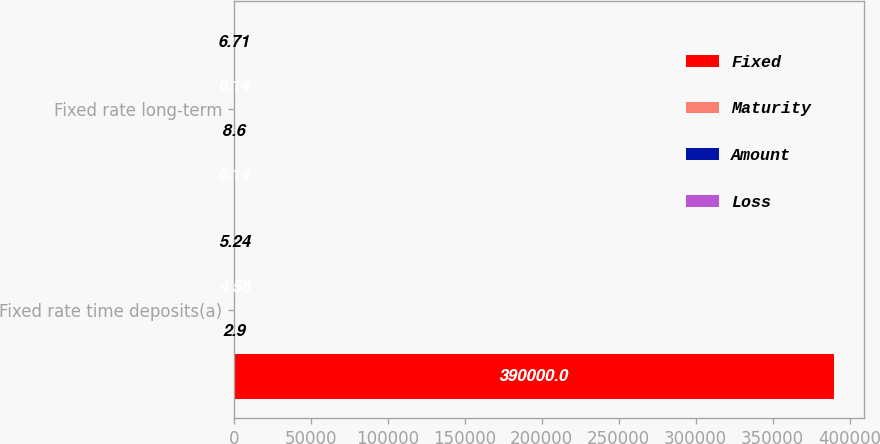<chart> <loc_0><loc_0><loc_500><loc_500><stacked_bar_chart><ecel><fcel>Fixed rate time deposits(a)<fcel>Fixed rate long-term<nl><fcel>Fixed<fcel>390000<fcel>6.14<nl><fcel>Maturity<fcel>2.9<fcel>8.6<nl><fcel>Amount<fcel>4.58<fcel>6.14<nl><fcel>Loss<fcel>5.24<fcel>6.71<nl></chart> 